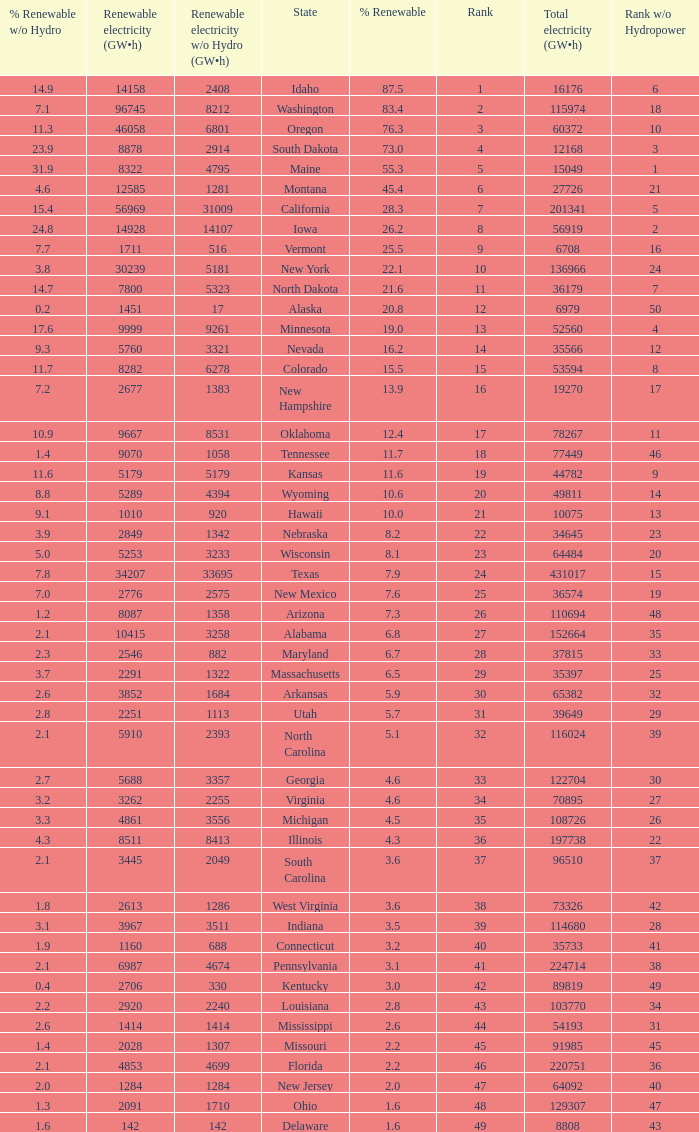Which states have renewable electricity equal to 9667 (gw×h)? Oklahoma. 